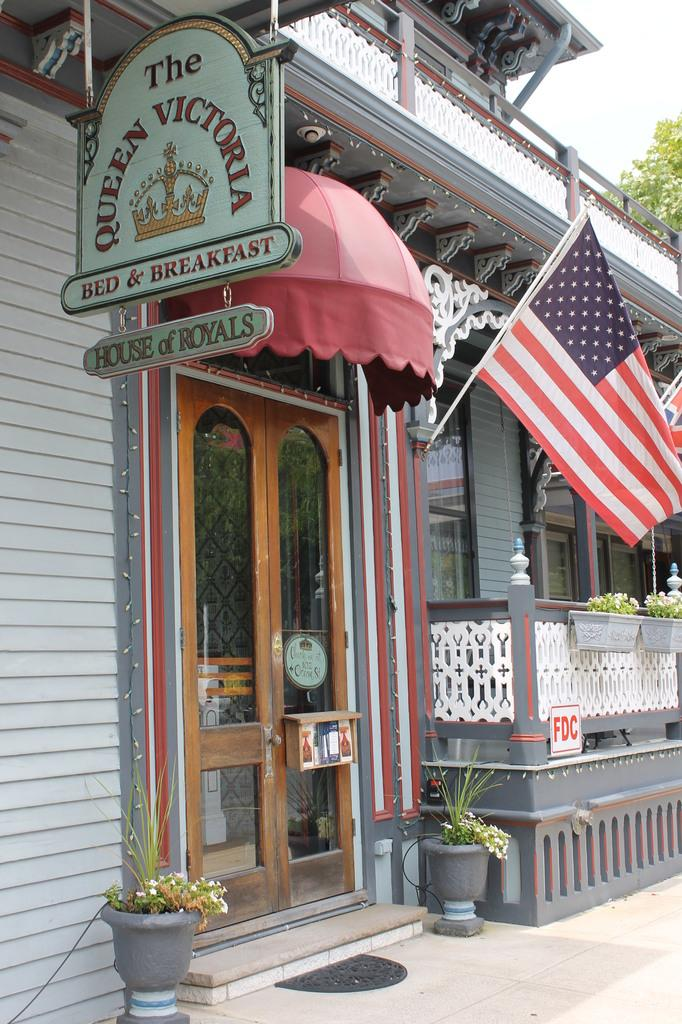<image>
Render a clear and concise summary of the photo. Queen Victoria Bed and breakfast  with red awning and american flag 